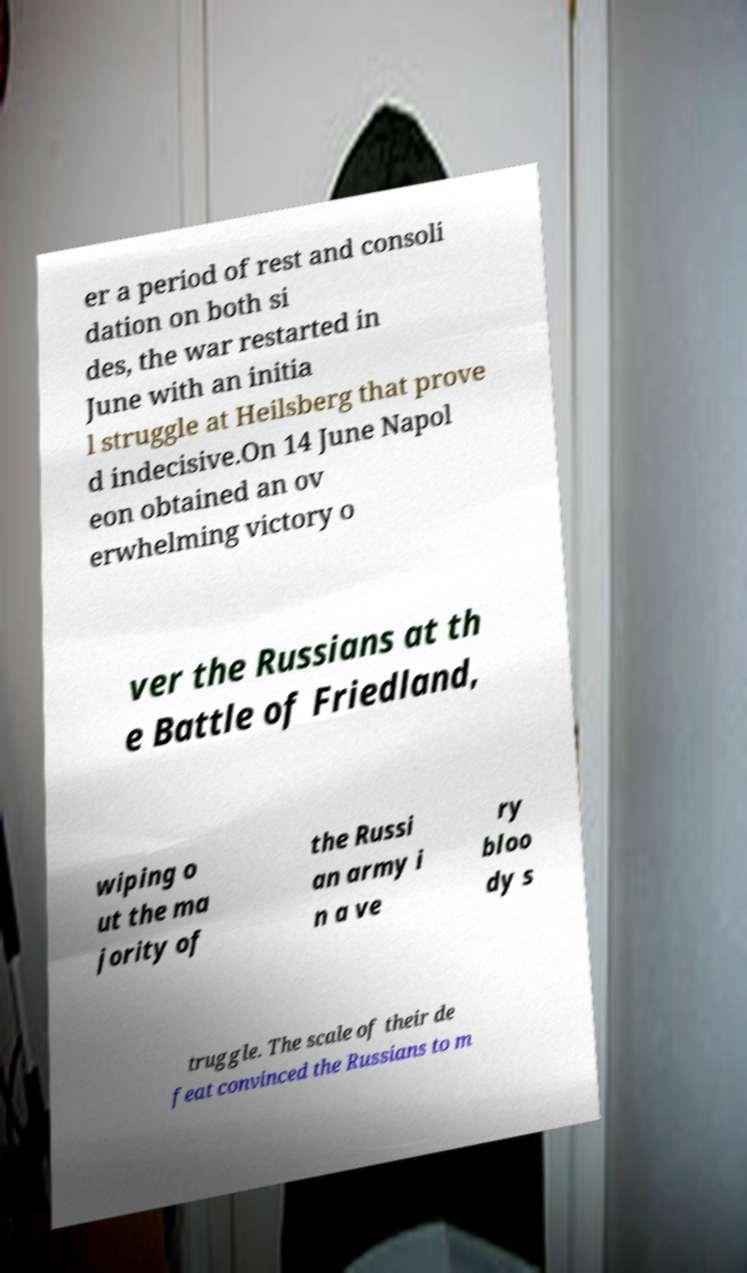Could you assist in decoding the text presented in this image and type it out clearly? er a period of rest and consoli dation on both si des, the war restarted in June with an initia l struggle at Heilsberg that prove d indecisive.On 14 June Napol eon obtained an ov erwhelming victory o ver the Russians at th e Battle of Friedland, wiping o ut the ma jority of the Russi an army i n a ve ry bloo dy s truggle. The scale of their de feat convinced the Russians to m 